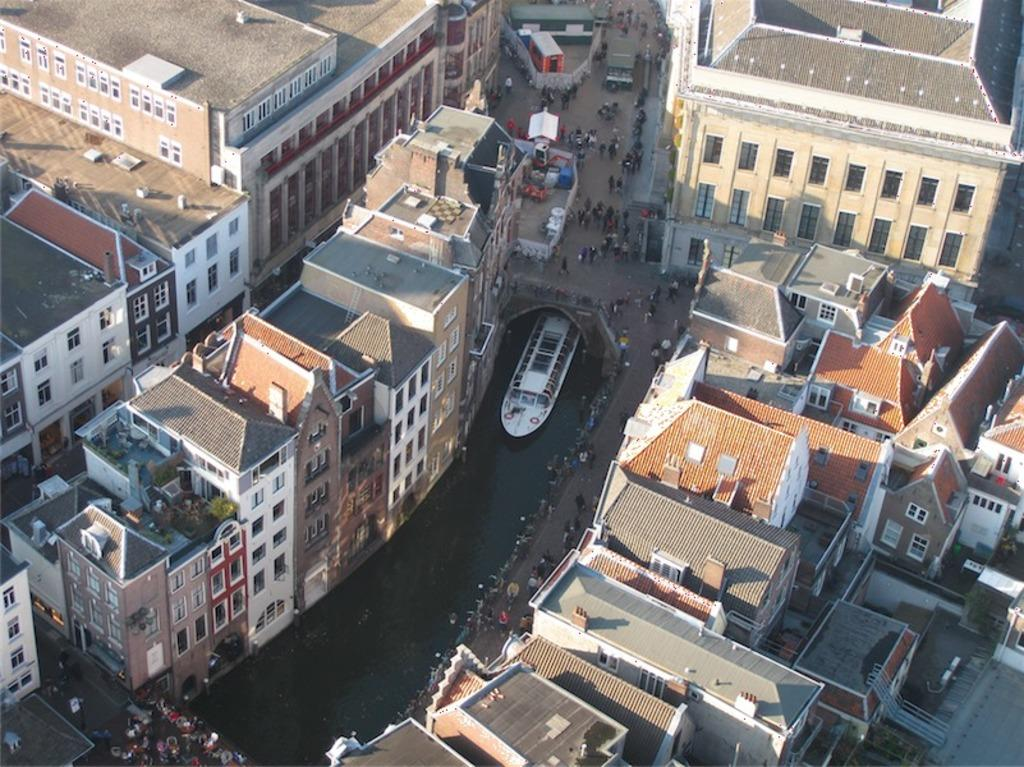What type of structures can be seen in the image? There are buildings in the image. What is located on the water in the image? There is a ship on the water in the image. Are there any human figures present in the image? Yes, there are people standing in the image. How many combs are being used by the people in the image? There is no indication of combs being used in the image. How many legs can be seen on the people in the image? While it is likely that the people in the image have legs, we cannot determine the exact number from the image alone. 